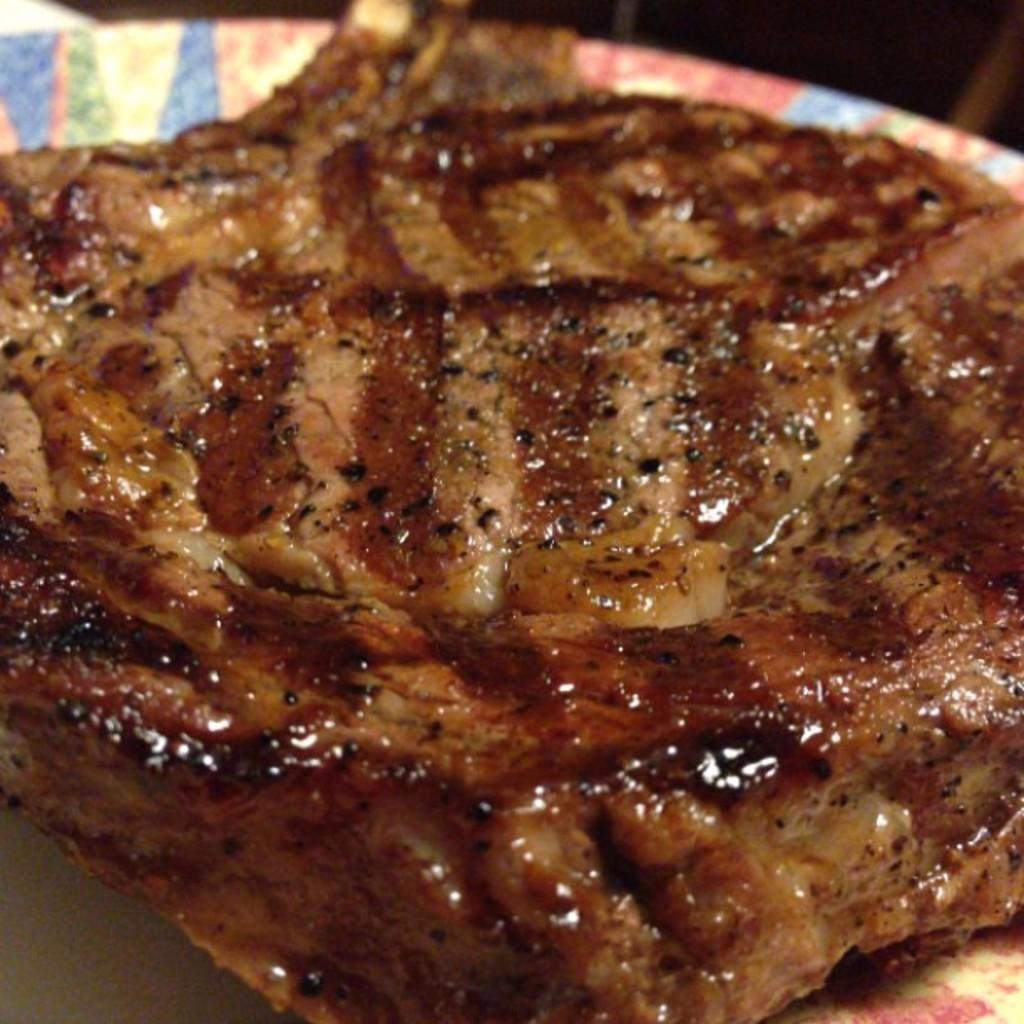Can you describe this image briefly? In this image we can see meat placed on the table. 